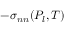Convert formula to latex. <formula><loc_0><loc_0><loc_500><loc_500>- \sigma _ { n n } ( P _ { l } , T )</formula> 